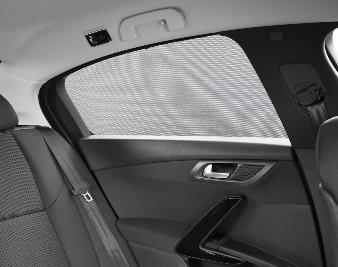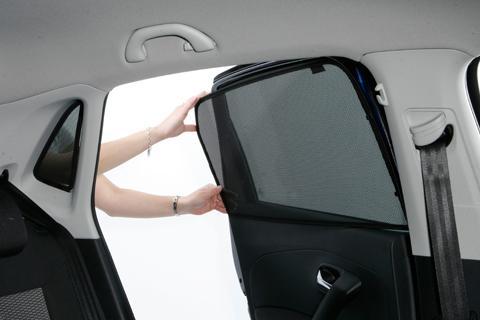The first image is the image on the left, the second image is the image on the right. For the images shown, is this caption "A human arm is visible on the right image." true? Answer yes or no. Yes. 